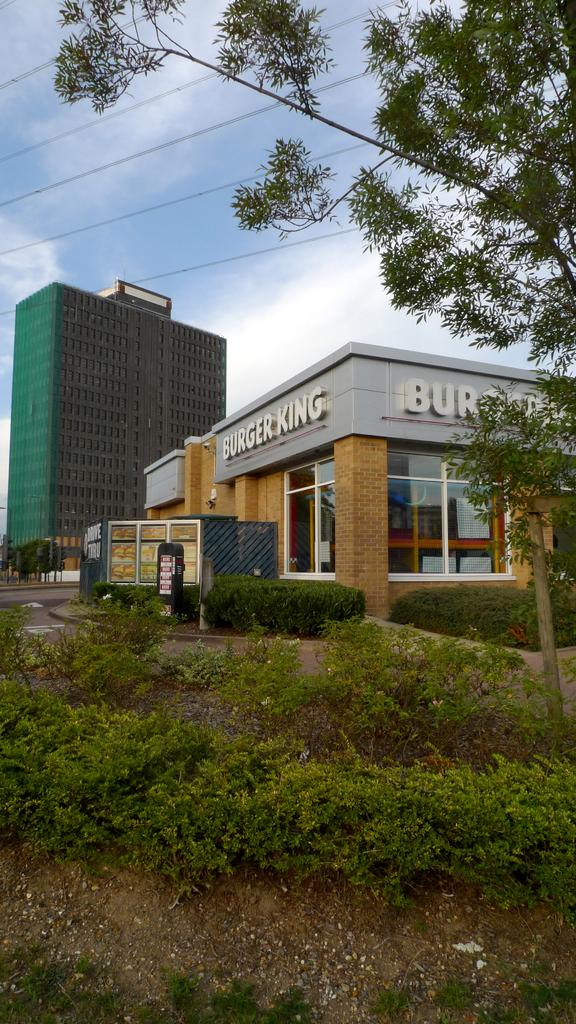What types of living organisms can be seen in the image? Plants and trees are visible in the image. What type of man-made structures can be seen in the image? There are buildings in the image. What type of pathway is present in the image? There is a road in the image. What type of vegetation is present in the image? Trees are present in the image. What type of utility infrastructure is present in the image? There are wires in the image. What is visible in the background of the image? The sky is visible in the background of the image. What can be seen in the sky in the image? There are clouds in the sky. Can you tell me what vegetable is being written on the thumb in the image? There is no vegetable being written on a thumb in the image. What type of writing can be seen on the plants in the image? There is no writing present on the plants in the image. 